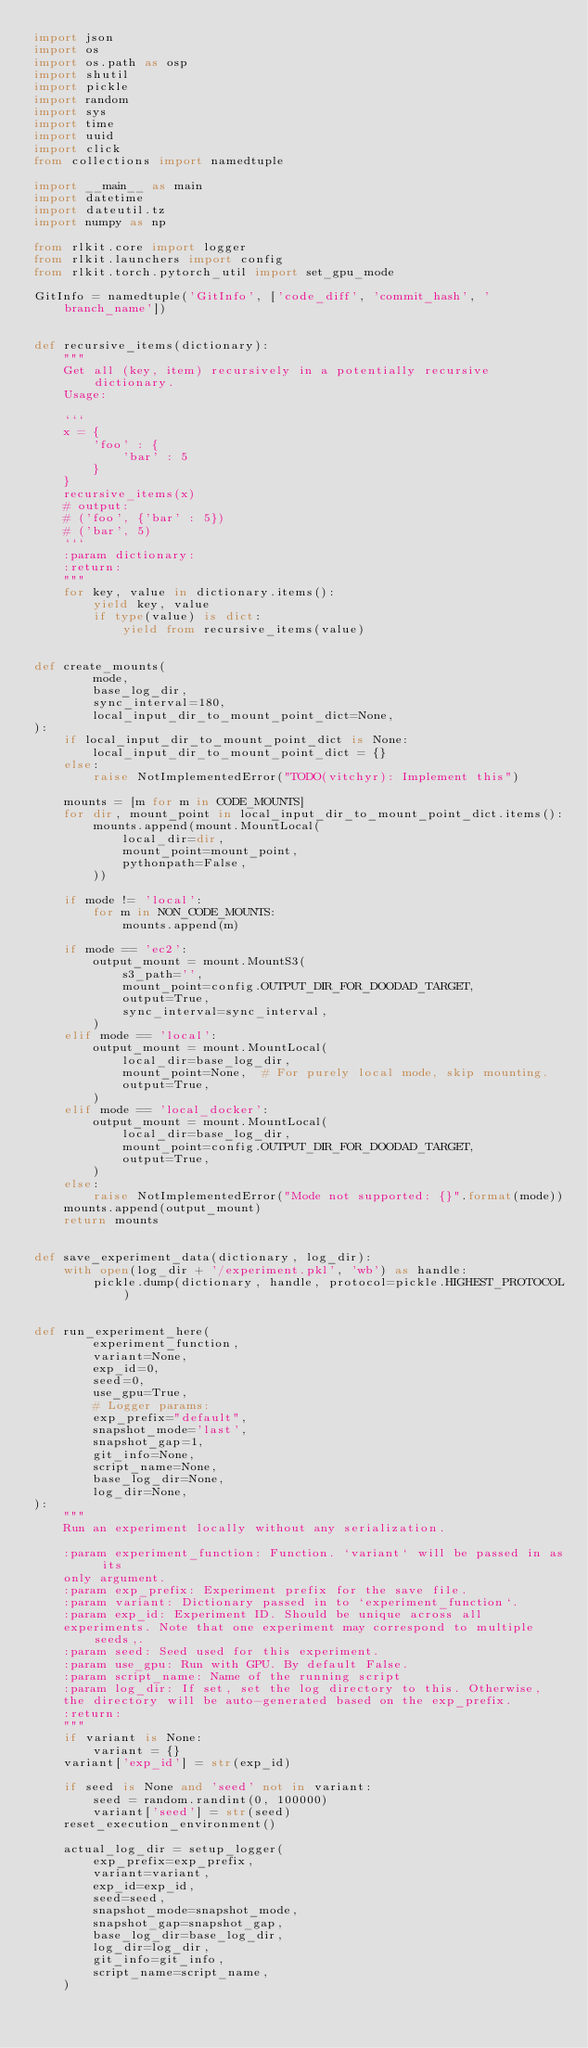Convert code to text. <code><loc_0><loc_0><loc_500><loc_500><_Python_>import json
import os
import os.path as osp
import shutil
import pickle
import random
import sys
import time
import uuid
import click
from collections import namedtuple

import __main__ as main
import datetime
import dateutil.tz
import numpy as np

from rlkit.core import logger
from rlkit.launchers import config
from rlkit.torch.pytorch_util import set_gpu_mode

GitInfo = namedtuple('GitInfo', ['code_diff', 'commit_hash', 'branch_name'])


def recursive_items(dictionary):
    """
    Get all (key, item) recursively in a potentially recursive dictionary.
    Usage:

    ```
    x = {
        'foo' : {
            'bar' : 5
        }
    }
    recursive_items(x)
    # output:
    # ('foo', {'bar' : 5})
    # ('bar', 5)
    ```
    :param dictionary:
    :return:
    """
    for key, value in dictionary.items():
        yield key, value
        if type(value) is dict:
            yield from recursive_items(value)


def create_mounts(
        mode,
        base_log_dir,
        sync_interval=180,
        local_input_dir_to_mount_point_dict=None,
):
    if local_input_dir_to_mount_point_dict is None:
        local_input_dir_to_mount_point_dict = {}
    else:
        raise NotImplementedError("TODO(vitchyr): Implement this")

    mounts = [m for m in CODE_MOUNTS]
    for dir, mount_point in local_input_dir_to_mount_point_dict.items():
        mounts.append(mount.MountLocal(
            local_dir=dir,
            mount_point=mount_point,
            pythonpath=False,
        ))

    if mode != 'local':
        for m in NON_CODE_MOUNTS:
            mounts.append(m)

    if mode == 'ec2':
        output_mount = mount.MountS3(
            s3_path='',
            mount_point=config.OUTPUT_DIR_FOR_DOODAD_TARGET,
            output=True,
            sync_interval=sync_interval,
        )
    elif mode == 'local':
        output_mount = mount.MountLocal(
            local_dir=base_log_dir,
            mount_point=None,  # For purely local mode, skip mounting.
            output=True,
        )
    elif mode == 'local_docker':
        output_mount = mount.MountLocal(
            local_dir=base_log_dir,
            mount_point=config.OUTPUT_DIR_FOR_DOODAD_TARGET,
            output=True,
        )
    else:
        raise NotImplementedError("Mode not supported: {}".format(mode))
    mounts.append(output_mount)
    return mounts


def save_experiment_data(dictionary, log_dir):
    with open(log_dir + '/experiment.pkl', 'wb') as handle:
        pickle.dump(dictionary, handle, protocol=pickle.HIGHEST_PROTOCOL)


def run_experiment_here(
        experiment_function,
        variant=None,
        exp_id=0,
        seed=0,
        use_gpu=True,
        # Logger params:
        exp_prefix="default",
        snapshot_mode='last',
        snapshot_gap=1,
        git_info=None,
        script_name=None,
        base_log_dir=None,
        log_dir=None,
):
    """
    Run an experiment locally without any serialization.

    :param experiment_function: Function. `variant` will be passed in as its
    only argument.
    :param exp_prefix: Experiment prefix for the save file.
    :param variant: Dictionary passed in to `experiment_function`.
    :param exp_id: Experiment ID. Should be unique across all
    experiments. Note that one experiment may correspond to multiple seeds,.
    :param seed: Seed used for this experiment.
    :param use_gpu: Run with GPU. By default False.
    :param script_name: Name of the running script
    :param log_dir: If set, set the log directory to this. Otherwise,
    the directory will be auto-generated based on the exp_prefix.
    :return:
    """
    if variant is None:
        variant = {}
    variant['exp_id'] = str(exp_id)

    if seed is None and 'seed' not in variant:
        seed = random.randint(0, 100000)
        variant['seed'] = str(seed)
    reset_execution_environment()

    actual_log_dir = setup_logger(
        exp_prefix=exp_prefix,
        variant=variant,
        exp_id=exp_id,
        seed=seed,
        snapshot_mode=snapshot_mode,
        snapshot_gap=snapshot_gap,
        base_log_dir=base_log_dir,
        log_dir=log_dir,
        git_info=git_info,
        script_name=script_name,
    )
</code> 